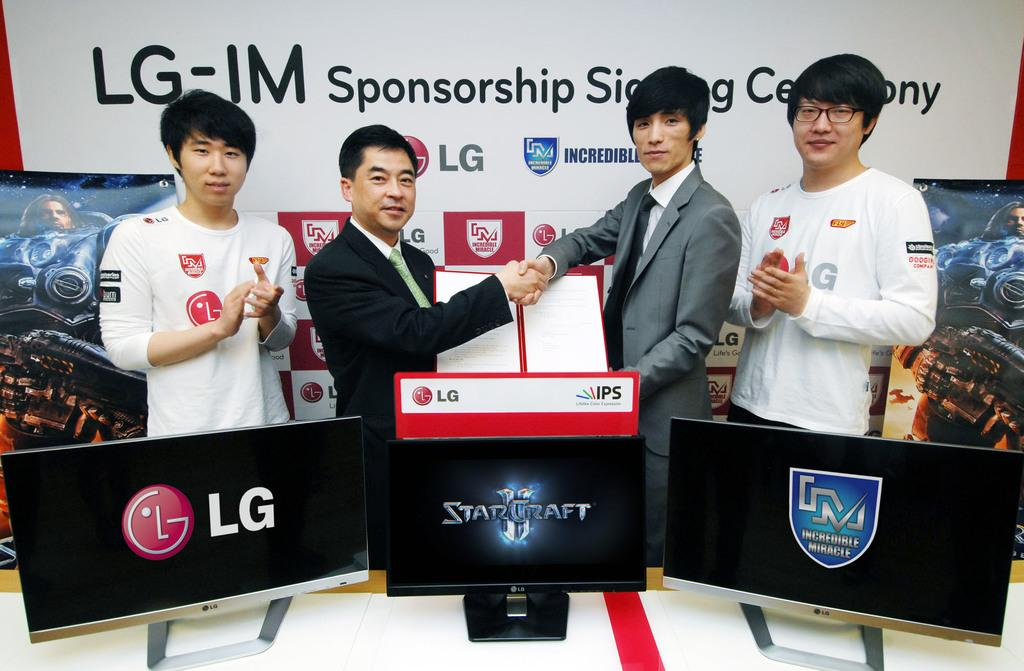What can be seen in the image? There are men standing in the image. Where are the men standing? The men are standing on the floor. What is present on the table in front of the men? There are display screens on a table in front of the men. What can be seen in the background of the image? There is an advertisement board in the background of the image. What type of sponge is being used by the men in the image? There is no sponge present in the image; the men are standing near display screens and an advertisement board. 